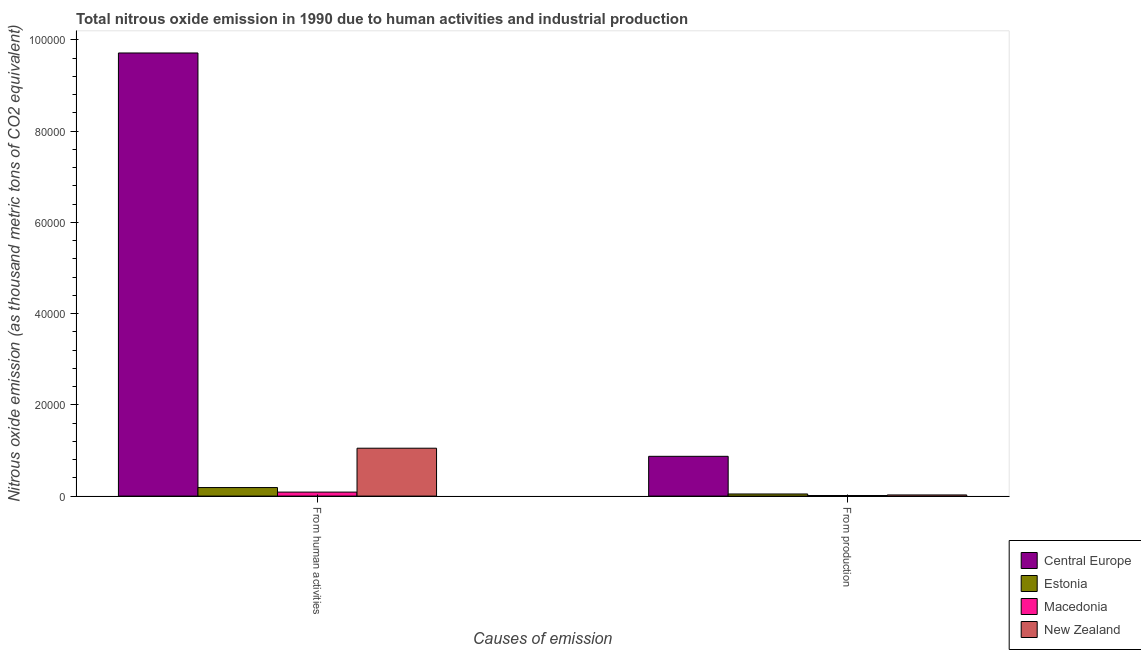Are the number of bars on each tick of the X-axis equal?
Provide a succinct answer. Yes. How many bars are there on the 1st tick from the right?
Offer a terse response. 4. What is the label of the 1st group of bars from the left?
Offer a very short reply. From human activities. What is the amount of emissions from human activities in Central Europe?
Provide a short and direct response. 9.71e+04. Across all countries, what is the maximum amount of emissions from human activities?
Ensure brevity in your answer.  9.71e+04. Across all countries, what is the minimum amount of emissions generated from industries?
Give a very brief answer. 128.3. In which country was the amount of emissions from human activities maximum?
Provide a succinct answer. Central Europe. In which country was the amount of emissions from human activities minimum?
Keep it short and to the point. Macedonia. What is the total amount of emissions generated from industries in the graph?
Keep it short and to the point. 9566.9. What is the difference between the amount of emissions from human activities in Macedonia and that in Estonia?
Give a very brief answer. -995. What is the difference between the amount of emissions generated from industries in Estonia and the amount of emissions from human activities in Macedonia?
Give a very brief answer. -411.7. What is the average amount of emissions from human activities per country?
Offer a very short reply. 2.76e+04. What is the difference between the amount of emissions from human activities and amount of emissions generated from industries in Estonia?
Offer a terse response. 1406.7. What is the ratio of the amount of emissions generated from industries in New Zealand to that in Estonia?
Your answer should be very brief. 0.54. Is the amount of emissions from human activities in Estonia less than that in Macedonia?
Give a very brief answer. No. In how many countries, is the amount of emissions from human activities greater than the average amount of emissions from human activities taken over all countries?
Provide a succinct answer. 1. What does the 1st bar from the left in From human activities represents?
Provide a succinct answer. Central Europe. What does the 1st bar from the right in From production represents?
Your response must be concise. New Zealand. How many bars are there?
Provide a short and direct response. 8. How many countries are there in the graph?
Your response must be concise. 4. What is the difference between two consecutive major ticks on the Y-axis?
Make the answer very short. 2.00e+04. Does the graph contain any zero values?
Your answer should be compact. No. Where does the legend appear in the graph?
Ensure brevity in your answer.  Bottom right. How are the legend labels stacked?
Offer a terse response. Vertical. What is the title of the graph?
Offer a very short reply. Total nitrous oxide emission in 1990 due to human activities and industrial production. What is the label or title of the X-axis?
Ensure brevity in your answer.  Causes of emission. What is the label or title of the Y-axis?
Offer a very short reply. Nitrous oxide emission (as thousand metric tons of CO2 equivalent). What is the Nitrous oxide emission (as thousand metric tons of CO2 equivalent) of Central Europe in From human activities?
Provide a short and direct response. 9.71e+04. What is the Nitrous oxide emission (as thousand metric tons of CO2 equivalent) in Estonia in From human activities?
Provide a succinct answer. 1872.9. What is the Nitrous oxide emission (as thousand metric tons of CO2 equivalent) of Macedonia in From human activities?
Offer a terse response. 877.9. What is the Nitrous oxide emission (as thousand metric tons of CO2 equivalent) of New Zealand in From human activities?
Provide a succinct answer. 1.05e+04. What is the Nitrous oxide emission (as thousand metric tons of CO2 equivalent) in Central Europe in From production?
Make the answer very short. 8719. What is the Nitrous oxide emission (as thousand metric tons of CO2 equivalent) of Estonia in From production?
Provide a succinct answer. 466.2. What is the Nitrous oxide emission (as thousand metric tons of CO2 equivalent) in Macedonia in From production?
Keep it short and to the point. 128.3. What is the Nitrous oxide emission (as thousand metric tons of CO2 equivalent) in New Zealand in From production?
Keep it short and to the point. 253.4. Across all Causes of emission, what is the maximum Nitrous oxide emission (as thousand metric tons of CO2 equivalent) in Central Europe?
Provide a succinct answer. 9.71e+04. Across all Causes of emission, what is the maximum Nitrous oxide emission (as thousand metric tons of CO2 equivalent) of Estonia?
Your answer should be very brief. 1872.9. Across all Causes of emission, what is the maximum Nitrous oxide emission (as thousand metric tons of CO2 equivalent) in Macedonia?
Ensure brevity in your answer.  877.9. Across all Causes of emission, what is the maximum Nitrous oxide emission (as thousand metric tons of CO2 equivalent) of New Zealand?
Keep it short and to the point. 1.05e+04. Across all Causes of emission, what is the minimum Nitrous oxide emission (as thousand metric tons of CO2 equivalent) in Central Europe?
Provide a succinct answer. 8719. Across all Causes of emission, what is the minimum Nitrous oxide emission (as thousand metric tons of CO2 equivalent) of Estonia?
Provide a succinct answer. 466.2. Across all Causes of emission, what is the minimum Nitrous oxide emission (as thousand metric tons of CO2 equivalent) in Macedonia?
Your answer should be compact. 128.3. Across all Causes of emission, what is the minimum Nitrous oxide emission (as thousand metric tons of CO2 equivalent) in New Zealand?
Your answer should be very brief. 253.4. What is the total Nitrous oxide emission (as thousand metric tons of CO2 equivalent) in Central Europe in the graph?
Your answer should be compact. 1.06e+05. What is the total Nitrous oxide emission (as thousand metric tons of CO2 equivalent) of Estonia in the graph?
Keep it short and to the point. 2339.1. What is the total Nitrous oxide emission (as thousand metric tons of CO2 equivalent) in Macedonia in the graph?
Your answer should be very brief. 1006.2. What is the total Nitrous oxide emission (as thousand metric tons of CO2 equivalent) in New Zealand in the graph?
Your response must be concise. 1.07e+04. What is the difference between the Nitrous oxide emission (as thousand metric tons of CO2 equivalent) in Central Europe in From human activities and that in From production?
Offer a very short reply. 8.84e+04. What is the difference between the Nitrous oxide emission (as thousand metric tons of CO2 equivalent) of Estonia in From human activities and that in From production?
Offer a very short reply. 1406.7. What is the difference between the Nitrous oxide emission (as thousand metric tons of CO2 equivalent) in Macedonia in From human activities and that in From production?
Offer a terse response. 749.6. What is the difference between the Nitrous oxide emission (as thousand metric tons of CO2 equivalent) of New Zealand in From human activities and that in From production?
Offer a terse response. 1.02e+04. What is the difference between the Nitrous oxide emission (as thousand metric tons of CO2 equivalent) in Central Europe in From human activities and the Nitrous oxide emission (as thousand metric tons of CO2 equivalent) in Estonia in From production?
Keep it short and to the point. 9.66e+04. What is the difference between the Nitrous oxide emission (as thousand metric tons of CO2 equivalent) in Central Europe in From human activities and the Nitrous oxide emission (as thousand metric tons of CO2 equivalent) in Macedonia in From production?
Offer a very short reply. 9.70e+04. What is the difference between the Nitrous oxide emission (as thousand metric tons of CO2 equivalent) of Central Europe in From human activities and the Nitrous oxide emission (as thousand metric tons of CO2 equivalent) of New Zealand in From production?
Offer a very short reply. 9.69e+04. What is the difference between the Nitrous oxide emission (as thousand metric tons of CO2 equivalent) of Estonia in From human activities and the Nitrous oxide emission (as thousand metric tons of CO2 equivalent) of Macedonia in From production?
Provide a short and direct response. 1744.6. What is the difference between the Nitrous oxide emission (as thousand metric tons of CO2 equivalent) in Estonia in From human activities and the Nitrous oxide emission (as thousand metric tons of CO2 equivalent) in New Zealand in From production?
Give a very brief answer. 1619.5. What is the difference between the Nitrous oxide emission (as thousand metric tons of CO2 equivalent) of Macedonia in From human activities and the Nitrous oxide emission (as thousand metric tons of CO2 equivalent) of New Zealand in From production?
Provide a succinct answer. 624.5. What is the average Nitrous oxide emission (as thousand metric tons of CO2 equivalent) of Central Europe per Causes of emission?
Keep it short and to the point. 5.29e+04. What is the average Nitrous oxide emission (as thousand metric tons of CO2 equivalent) of Estonia per Causes of emission?
Give a very brief answer. 1169.55. What is the average Nitrous oxide emission (as thousand metric tons of CO2 equivalent) in Macedonia per Causes of emission?
Provide a short and direct response. 503.1. What is the average Nitrous oxide emission (as thousand metric tons of CO2 equivalent) in New Zealand per Causes of emission?
Your answer should be very brief. 5374.55. What is the difference between the Nitrous oxide emission (as thousand metric tons of CO2 equivalent) of Central Europe and Nitrous oxide emission (as thousand metric tons of CO2 equivalent) of Estonia in From human activities?
Offer a terse response. 9.52e+04. What is the difference between the Nitrous oxide emission (as thousand metric tons of CO2 equivalent) of Central Europe and Nitrous oxide emission (as thousand metric tons of CO2 equivalent) of Macedonia in From human activities?
Make the answer very short. 9.62e+04. What is the difference between the Nitrous oxide emission (as thousand metric tons of CO2 equivalent) in Central Europe and Nitrous oxide emission (as thousand metric tons of CO2 equivalent) in New Zealand in From human activities?
Give a very brief answer. 8.66e+04. What is the difference between the Nitrous oxide emission (as thousand metric tons of CO2 equivalent) of Estonia and Nitrous oxide emission (as thousand metric tons of CO2 equivalent) of Macedonia in From human activities?
Your response must be concise. 995. What is the difference between the Nitrous oxide emission (as thousand metric tons of CO2 equivalent) of Estonia and Nitrous oxide emission (as thousand metric tons of CO2 equivalent) of New Zealand in From human activities?
Ensure brevity in your answer.  -8622.8. What is the difference between the Nitrous oxide emission (as thousand metric tons of CO2 equivalent) of Macedonia and Nitrous oxide emission (as thousand metric tons of CO2 equivalent) of New Zealand in From human activities?
Your answer should be very brief. -9617.8. What is the difference between the Nitrous oxide emission (as thousand metric tons of CO2 equivalent) in Central Europe and Nitrous oxide emission (as thousand metric tons of CO2 equivalent) in Estonia in From production?
Give a very brief answer. 8252.8. What is the difference between the Nitrous oxide emission (as thousand metric tons of CO2 equivalent) of Central Europe and Nitrous oxide emission (as thousand metric tons of CO2 equivalent) of Macedonia in From production?
Your answer should be very brief. 8590.7. What is the difference between the Nitrous oxide emission (as thousand metric tons of CO2 equivalent) of Central Europe and Nitrous oxide emission (as thousand metric tons of CO2 equivalent) of New Zealand in From production?
Offer a very short reply. 8465.6. What is the difference between the Nitrous oxide emission (as thousand metric tons of CO2 equivalent) in Estonia and Nitrous oxide emission (as thousand metric tons of CO2 equivalent) in Macedonia in From production?
Make the answer very short. 337.9. What is the difference between the Nitrous oxide emission (as thousand metric tons of CO2 equivalent) of Estonia and Nitrous oxide emission (as thousand metric tons of CO2 equivalent) of New Zealand in From production?
Give a very brief answer. 212.8. What is the difference between the Nitrous oxide emission (as thousand metric tons of CO2 equivalent) of Macedonia and Nitrous oxide emission (as thousand metric tons of CO2 equivalent) of New Zealand in From production?
Offer a very short reply. -125.1. What is the ratio of the Nitrous oxide emission (as thousand metric tons of CO2 equivalent) in Central Europe in From human activities to that in From production?
Your answer should be compact. 11.14. What is the ratio of the Nitrous oxide emission (as thousand metric tons of CO2 equivalent) of Estonia in From human activities to that in From production?
Provide a succinct answer. 4.02. What is the ratio of the Nitrous oxide emission (as thousand metric tons of CO2 equivalent) in Macedonia in From human activities to that in From production?
Offer a terse response. 6.84. What is the ratio of the Nitrous oxide emission (as thousand metric tons of CO2 equivalent) in New Zealand in From human activities to that in From production?
Give a very brief answer. 41.42. What is the difference between the highest and the second highest Nitrous oxide emission (as thousand metric tons of CO2 equivalent) of Central Europe?
Your response must be concise. 8.84e+04. What is the difference between the highest and the second highest Nitrous oxide emission (as thousand metric tons of CO2 equivalent) of Estonia?
Provide a short and direct response. 1406.7. What is the difference between the highest and the second highest Nitrous oxide emission (as thousand metric tons of CO2 equivalent) of Macedonia?
Your response must be concise. 749.6. What is the difference between the highest and the second highest Nitrous oxide emission (as thousand metric tons of CO2 equivalent) in New Zealand?
Offer a terse response. 1.02e+04. What is the difference between the highest and the lowest Nitrous oxide emission (as thousand metric tons of CO2 equivalent) of Central Europe?
Keep it short and to the point. 8.84e+04. What is the difference between the highest and the lowest Nitrous oxide emission (as thousand metric tons of CO2 equivalent) in Estonia?
Provide a succinct answer. 1406.7. What is the difference between the highest and the lowest Nitrous oxide emission (as thousand metric tons of CO2 equivalent) in Macedonia?
Offer a very short reply. 749.6. What is the difference between the highest and the lowest Nitrous oxide emission (as thousand metric tons of CO2 equivalent) in New Zealand?
Provide a short and direct response. 1.02e+04. 